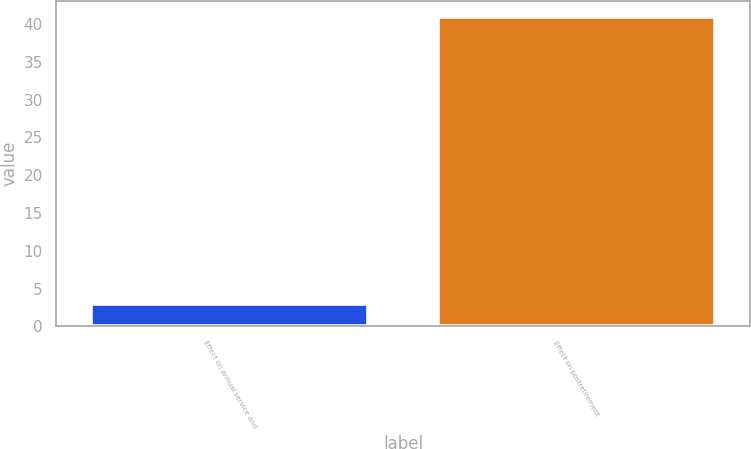Convert chart to OTSL. <chart><loc_0><loc_0><loc_500><loc_500><bar_chart><fcel>Effect on annual service and<fcel>Effect on postretirement<nl><fcel>3<fcel>41<nl></chart> 